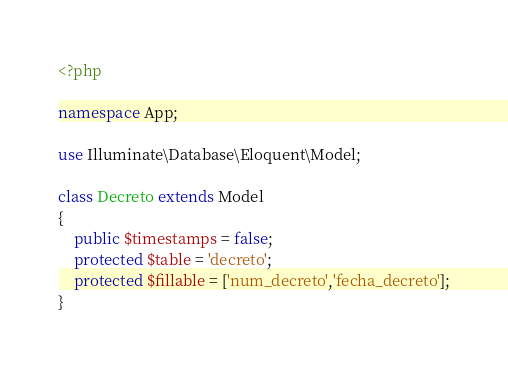Convert code to text. <code><loc_0><loc_0><loc_500><loc_500><_PHP_><?php

namespace App;

use Illuminate\Database\Eloquent\Model;

class Decreto extends Model
{
    public $timestamps = false;
    protected $table = 'decreto';
    protected $fillable = ['num_decreto','fecha_decreto'];
}
</code> 